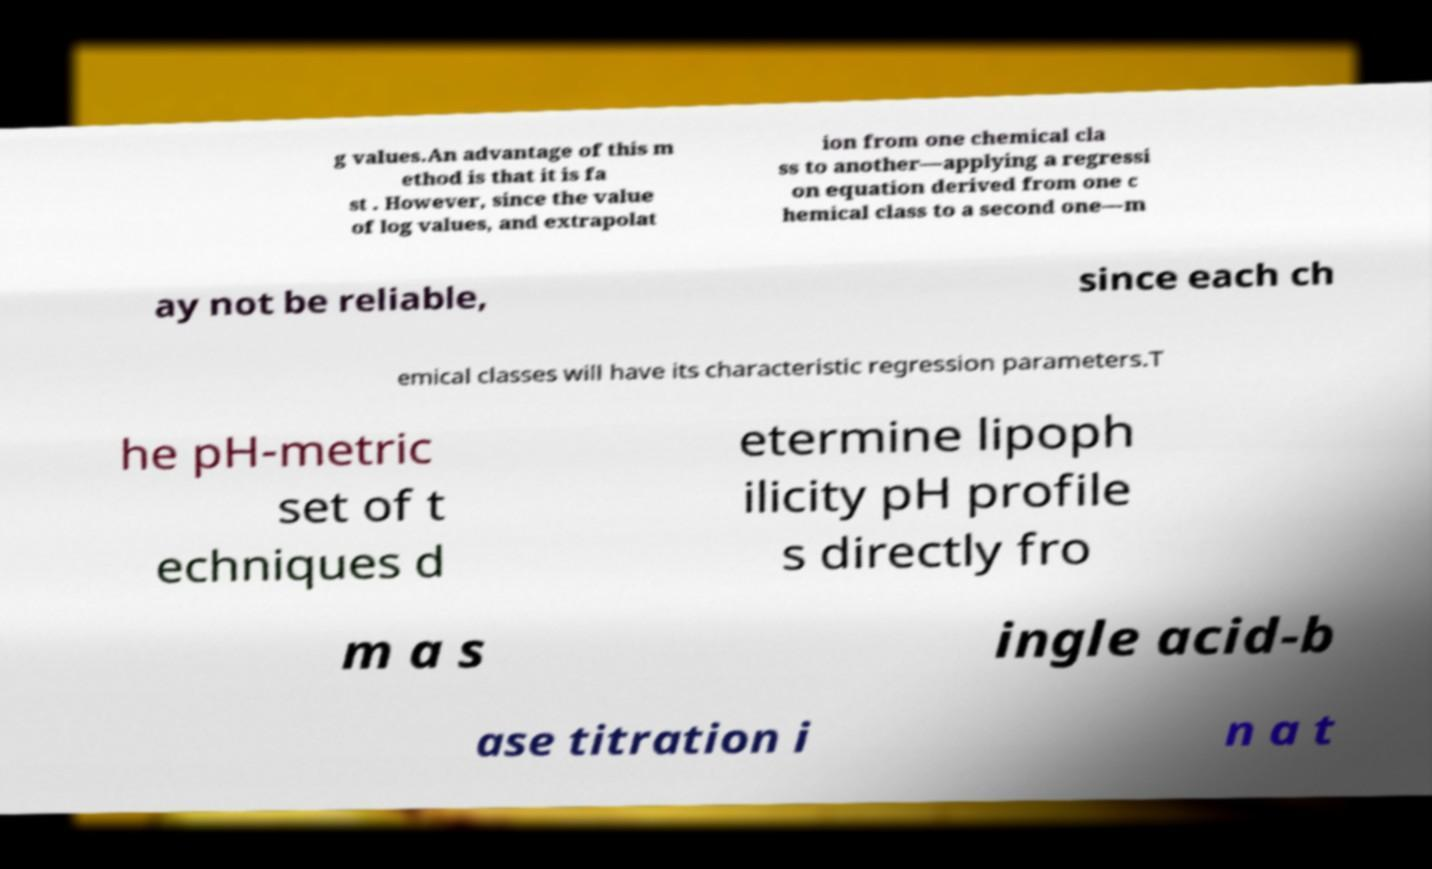I need the written content from this picture converted into text. Can you do that? g values.An advantage of this m ethod is that it is fa st . However, since the value of log values, and extrapolat ion from one chemical cla ss to another—applying a regressi on equation derived from one c hemical class to a second one—m ay not be reliable, since each ch emical classes will have its characteristic regression parameters.T he pH-metric set of t echniques d etermine lipoph ilicity pH profile s directly fro m a s ingle acid-b ase titration i n a t 